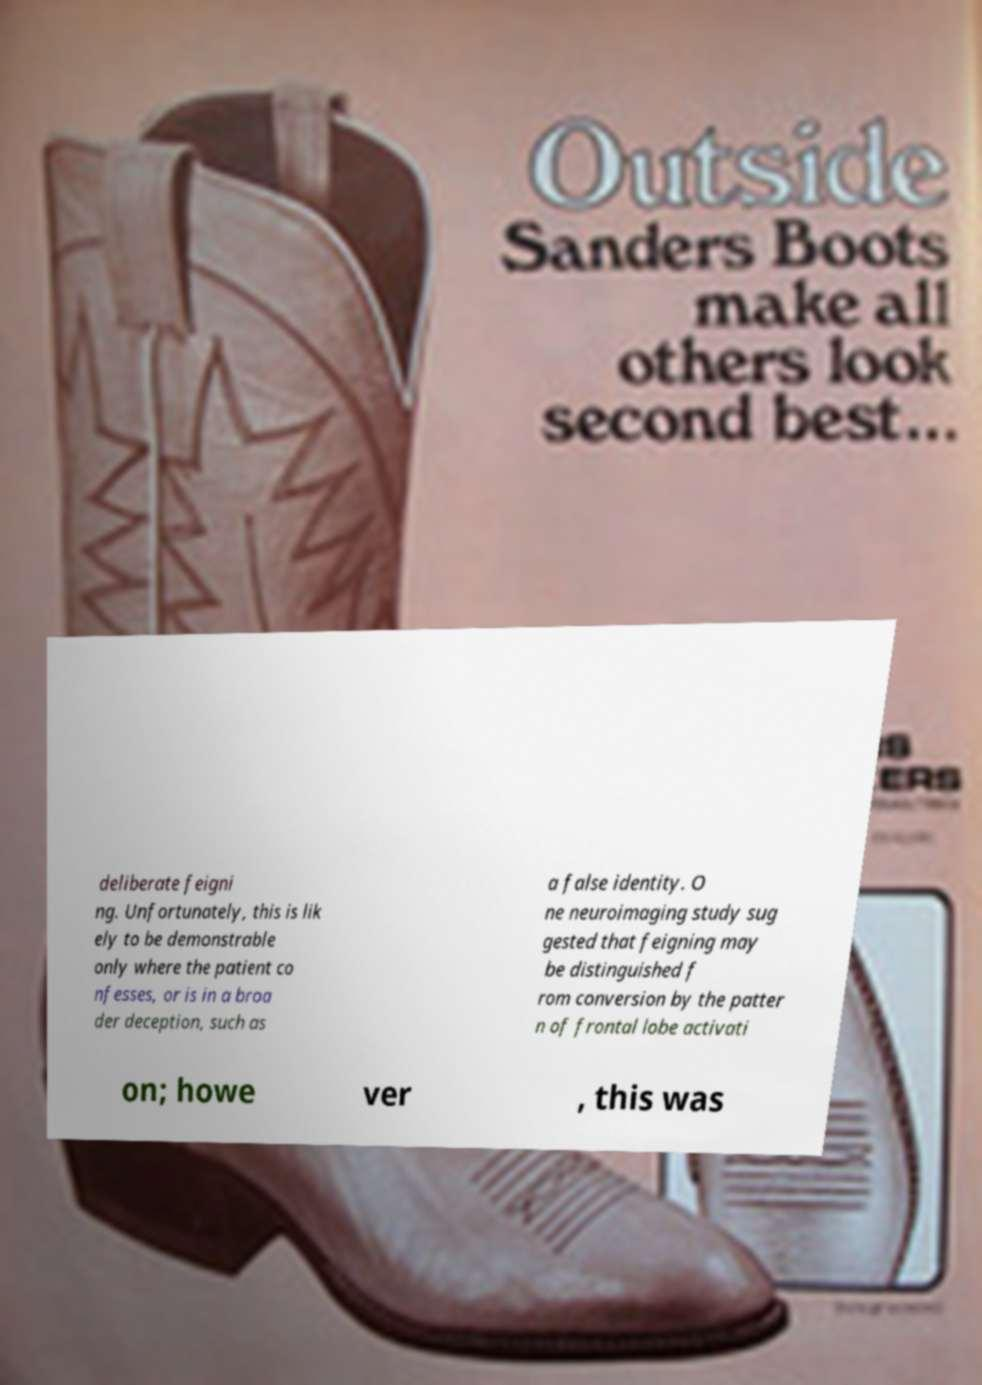Can you accurately transcribe the text from the provided image for me? deliberate feigni ng. Unfortunately, this is lik ely to be demonstrable only where the patient co nfesses, or is in a broa der deception, such as a false identity. O ne neuroimaging study sug gested that feigning may be distinguished f rom conversion by the patter n of frontal lobe activati on; howe ver , this was 